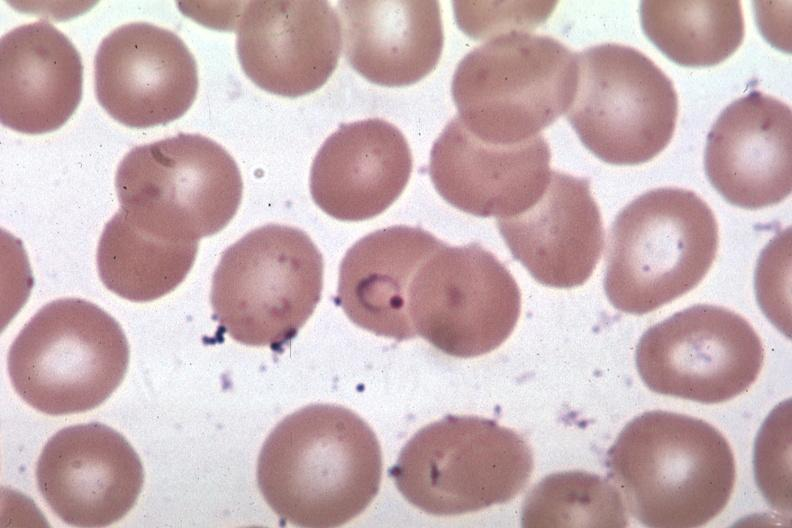what is present?
Answer the question using a single word or phrase. Malaria plasmodium vivax 